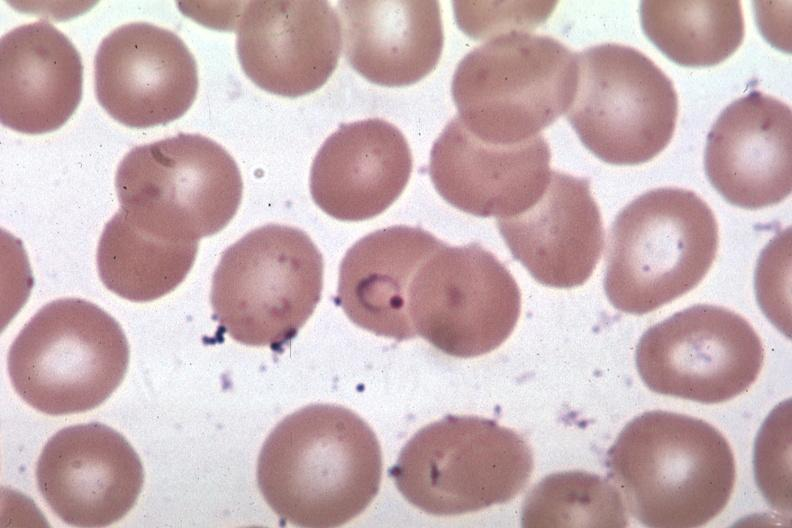what is present?
Answer the question using a single word or phrase. Malaria plasmodium vivax 